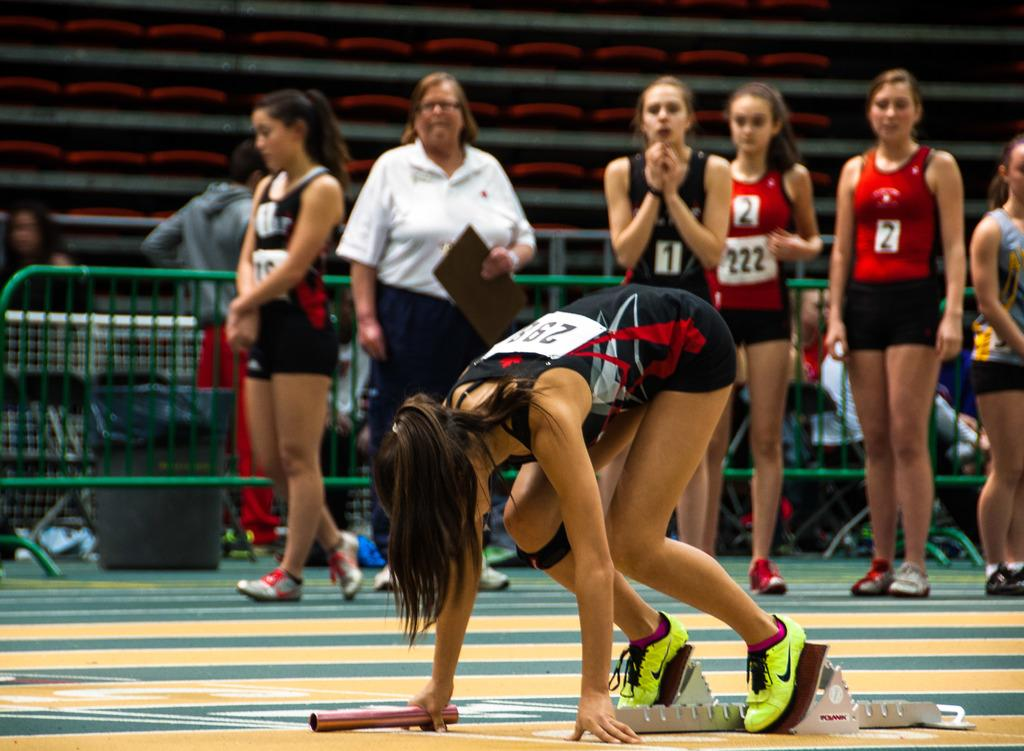How many people are in the image? There is a group of people in the image, but the exact number is not specified. What can be seen in the background of the image? There is a fence and a wall in the image. What type of temper do the lizards have in the image? There are no lizards present in the image. What is the shape of the nose of the person in the image? The facts provided do not mention any specific person or their nose shape. 